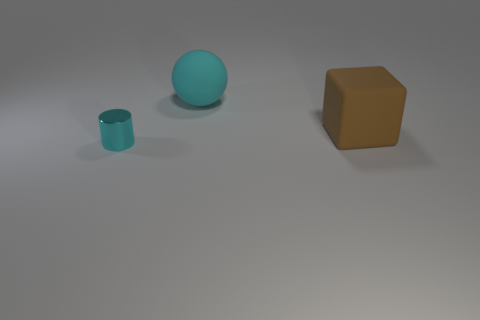Add 2 big green rubber cylinders. How many objects exist? 5 Subtract all cylinders. How many objects are left? 2 Add 2 cylinders. How many cylinders are left? 3 Add 1 spheres. How many spheres exist? 2 Subtract 0 purple cubes. How many objects are left? 3 Subtract all cylinders. Subtract all cyan cylinders. How many objects are left? 1 